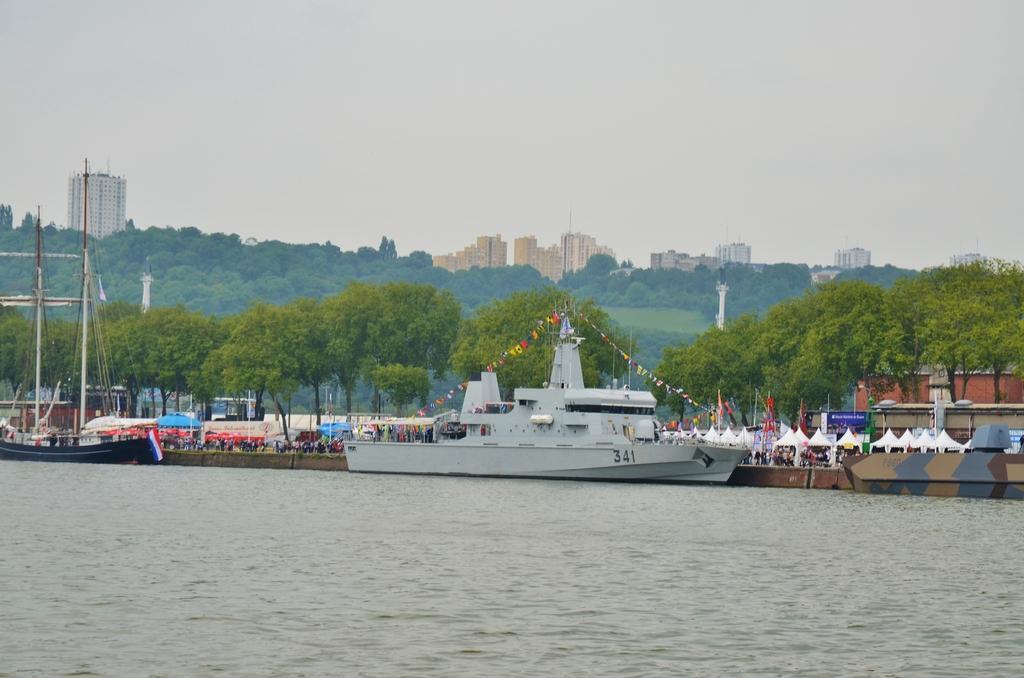Could you give a brief overview of what you see in this image? In this image there is water at the bottom. In the water there is a ship. Beside the ship there is a bridge on which there are so many people and so many tents. In the background there are so many trees. There are building in the middle of the background. On the left side there is another boat in the water. In the boat there is a flag. There are few flags in the ship. 